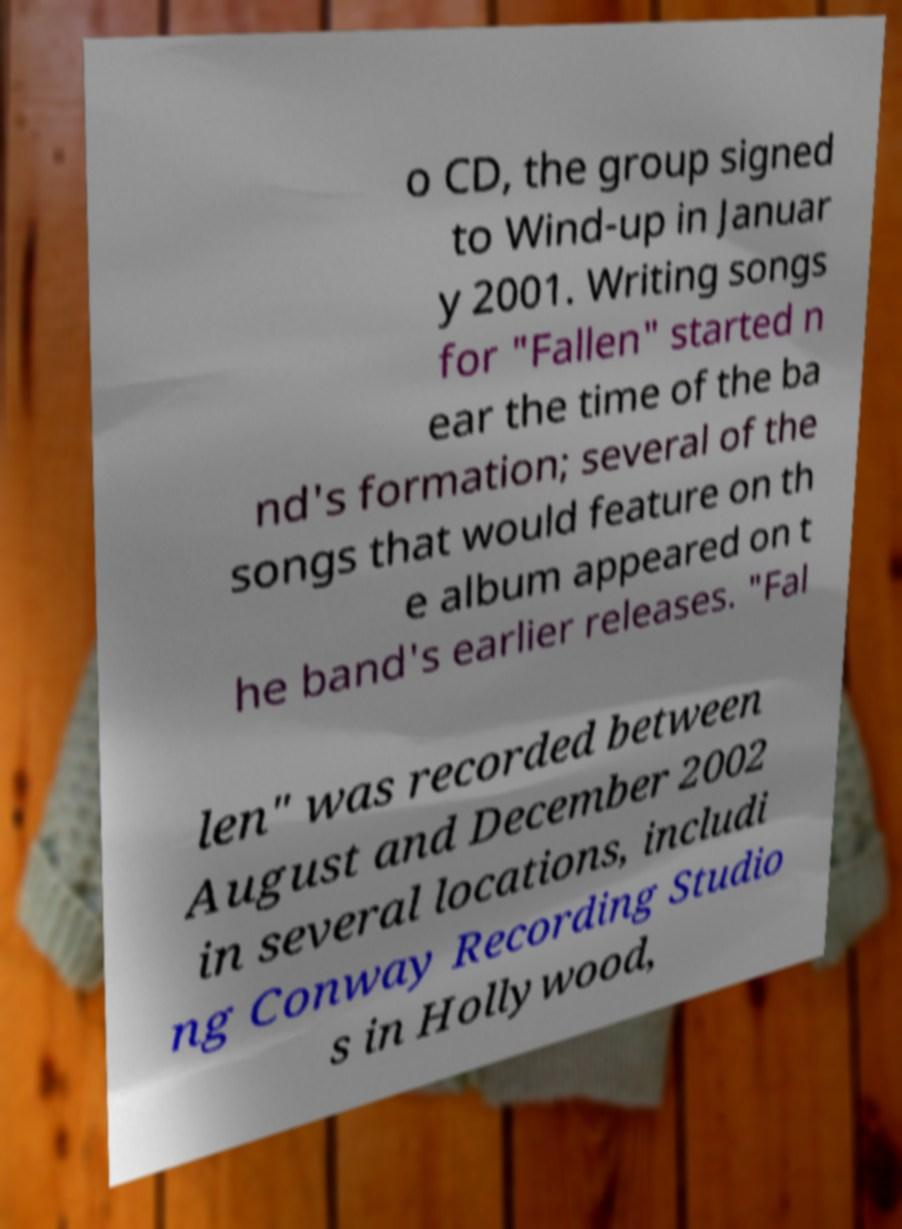Could you extract and type out the text from this image? o CD, the group signed to Wind-up in Januar y 2001. Writing songs for "Fallen" started n ear the time of the ba nd's formation; several of the songs that would feature on th e album appeared on t he band's earlier releases. "Fal len" was recorded between August and December 2002 in several locations, includi ng Conway Recording Studio s in Hollywood, 